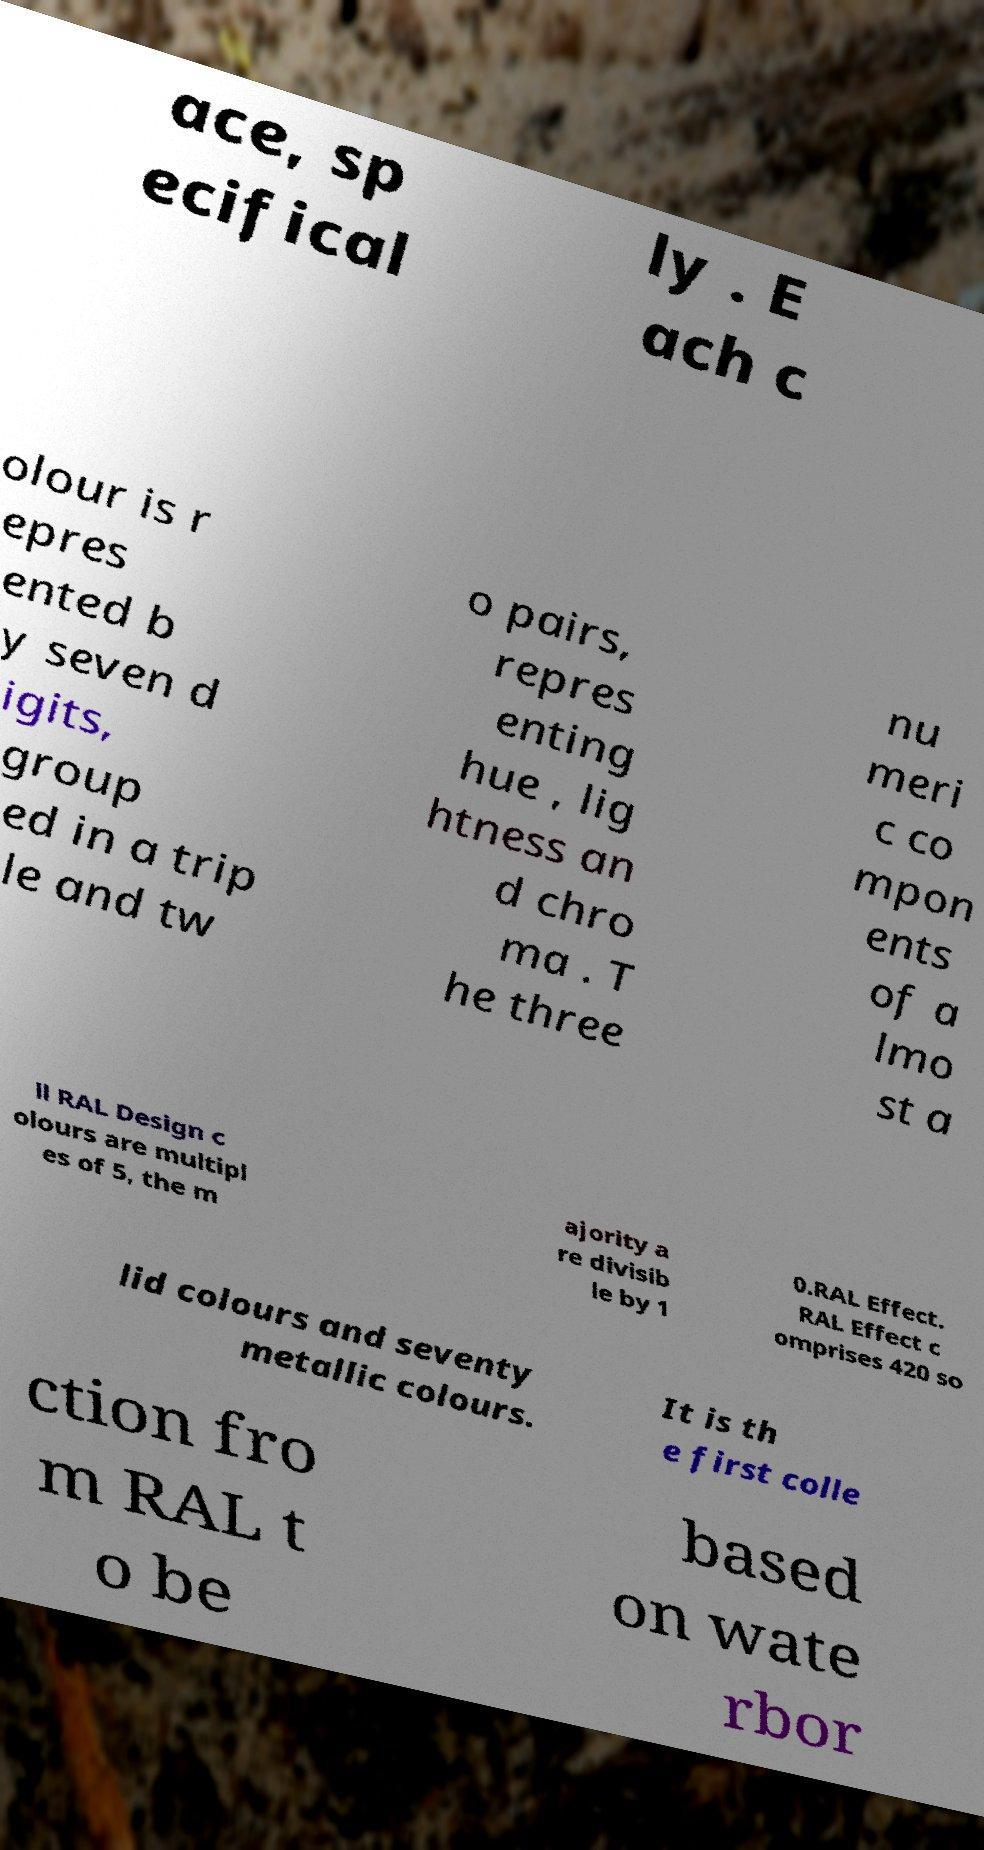I need the written content from this picture converted into text. Can you do that? ace, sp ecifical ly . E ach c olour is r epres ented b y seven d igits, group ed in a trip le and tw o pairs, repres enting hue , lig htness an d chro ma . T he three nu meri c co mpon ents of a lmo st a ll RAL Design c olours are multipl es of 5, the m ajority a re divisib le by 1 0.RAL Effect. RAL Effect c omprises 420 so lid colours and seventy metallic colours. It is th e first colle ction fro m RAL t o be based on wate rbor 